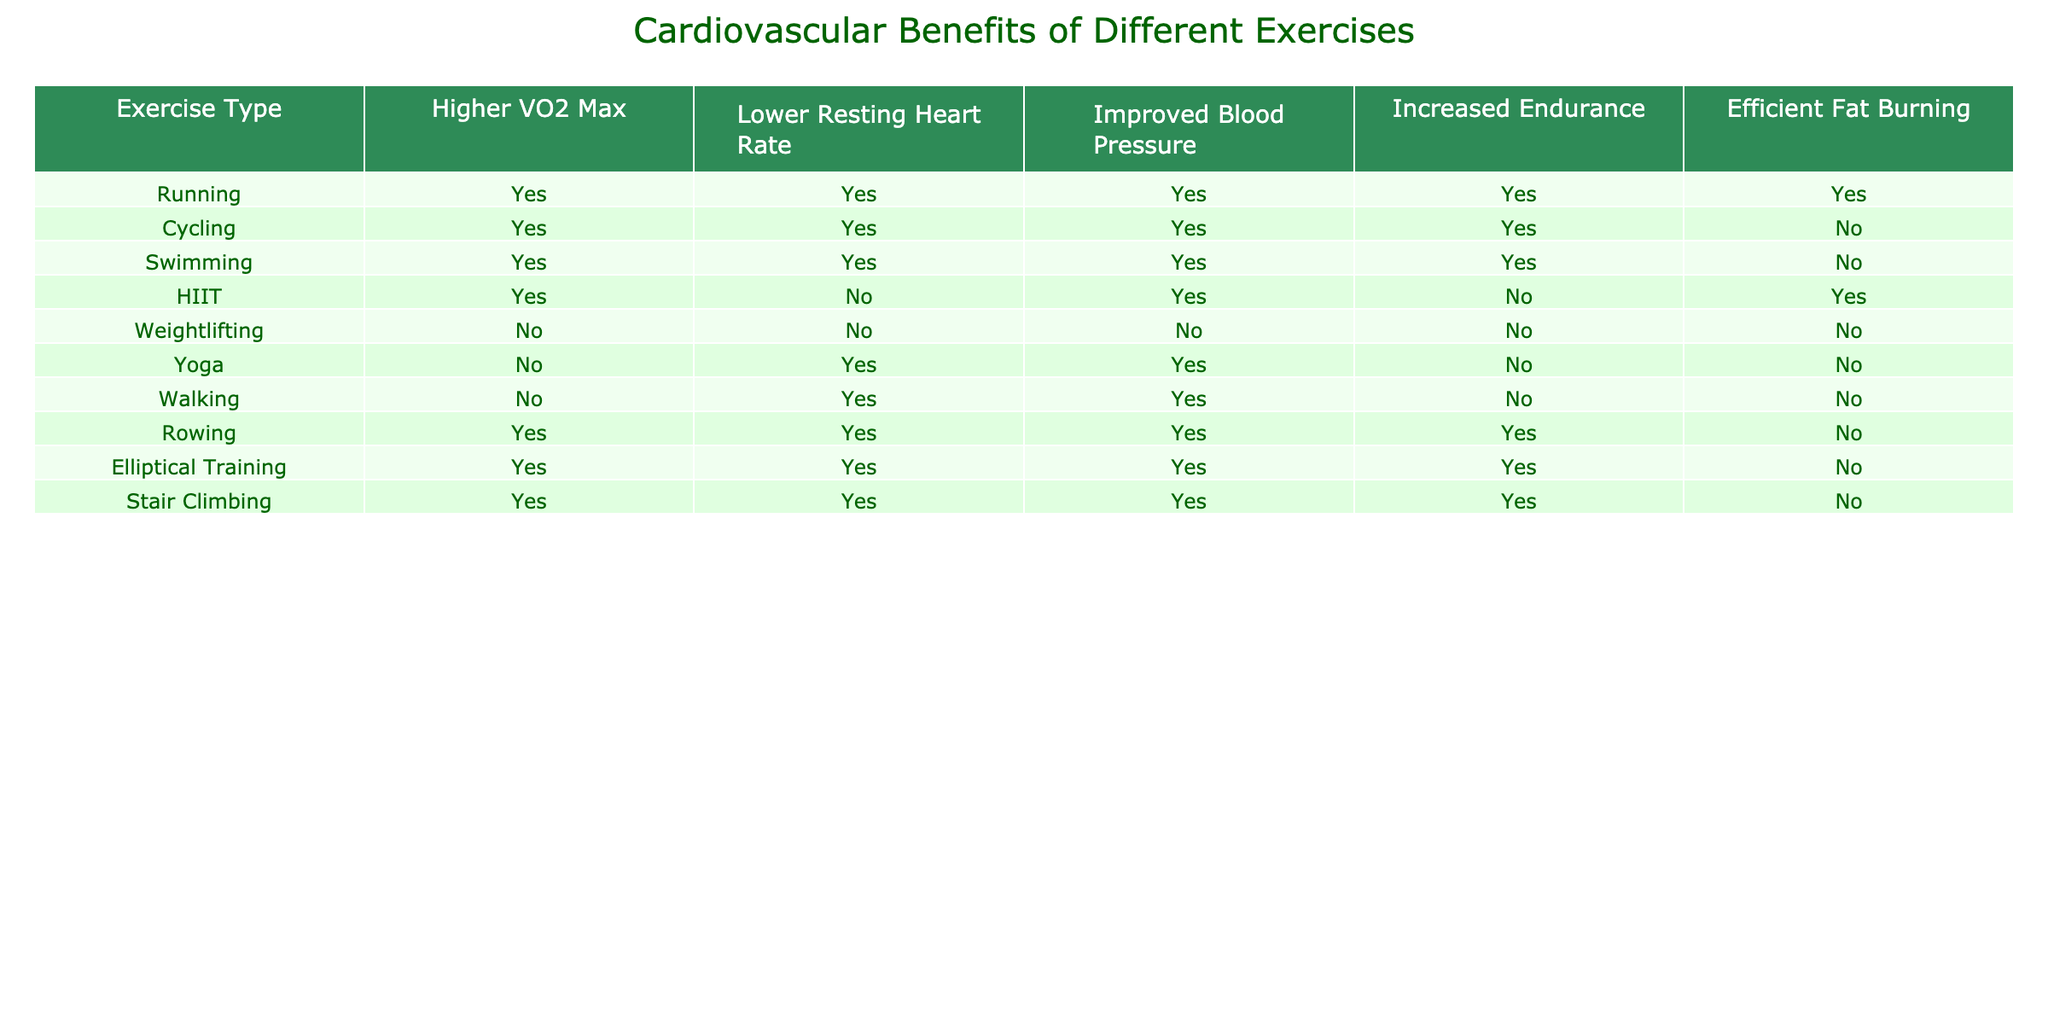What exercises improve blood pressure? To find the exercises that improve blood pressure, we look under the "Improved Blood Pressure" column for "TRUE" values. The exercises with "TRUE" in this column are Running, Cycling, Swimming, HIIT, Yoga, Walking, Rowing, Elliptical Training, and Stair Climbing.
Answer: Running, Cycling, Swimming, HIIT, Yoga, Walking, Rowing, Elliptical Training, Stair Climbing Does running lead to a lower resting heart rate? In the table, for the row corresponding to Running, the value under "Lower Resting Heart Rate" is "TRUE". This indicates that running does lead to a lower resting heart rate.
Answer: Yes Which exercises allow for efficient fat burning? We analyze the "Efficient Fat Burning" column for "TRUE" entries, which correspond to the exercises that allow for efficient fat burning. Only HIIT lists "TRUE", indicating it's the sole exercise that allows for this.
Answer: HIIT How many exercises lead to a higher VO2 max? We look under the "Higher VO2 Max" column for "TRUE" values and count the exercises that list "TRUE". There are 7 exercises (Running, Cycling, Swimming, HIIT, Rowing, Elliptical Training, and Stair Climbing) listed under that column.
Answer: 7 Is it true that weightlifting has all positive cardiovascular benefits? We need to look at the row for Weightlifting and check the values in each column. None of the values for Higher VO2 Max, Lower Resting Heart Rate, Improved Blood Pressure, Increased Endurance, or Efficient Fat Burning are "TRUE", confirming that weightlifting does not have any positive cardiovascular benefits.
Answer: No What is the total number of exercises that improve endurance? To find this, we look for "TRUE" values under the "Increased Endurance" column. Running, Cycling, Swimming, Rowing, Elliptical Training, and Stair Climbing all show "TRUE," totaling 6 exercises that improve endurance.
Answer: 6 Which exercise has the least cardiovascular benefits? We need to compare all the rows to find the exercise with the most "FALSE" values in the benefits columns. Weightlifting has 5 "FALSE" values, indicating it has the least cardiovascular benefits.
Answer: Weightlifting Among the exercises listed, which has the highest number of true benefits? We will count the number of "TRUE" values for each exercise. Running has 5, Cycling has 4, Swimming has 4, HIIT has 3, Rowing has 4, and both Yoga and Weightlifting have none. Thus, Running has the highest number of true benefits, with 5 out of 5.
Answer: Running 